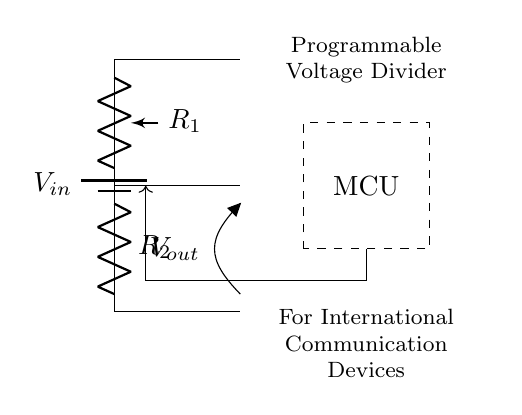What is the input voltage represented in the circuit? The input voltage is represented as "V_in" in the circuit diagram, which indicates the supply voltage for the programmable voltage divider.
Answer: V_in What type of component is R1? R1 is labeled as a "pR" in the diagram, indicating that it is a programmable resistor or potentiometer used to adjust the resistance dynamically.
Answer: Programmable resistor How is the output voltage labeled in the circuit? The output voltage is clearly labeled as "V_out" in the diagram, showing where the output can be taken from within the circuit setup.
Answer: V_out What components are in series to form the voltage divider? The two components in series are R1 and R2; they are connected in a sequential manner between the input voltage and ground, forming the voltage divider circuit.
Answer: R1 and R2 What is the role of the microcontroller (MCU) indicated in the circuit? The microcontroller (MCU) serves to control the programmable resistor based on the requirements of different communication devices, enabling adaptable power requirements during operations.
Answer: Control voltage adjustment What is the purpose of the dashed rectangle in the circuit? The dashed rectangle represents the microcontroller, indicating that it is a separate component tasked with processing control signals to adjust the voltage output, making the circuit adaptable.
Answer: Microcontroller What functionality does the programmable voltage divider provide in joint operations? The programmable voltage divider allows for the adaptation of voltage levels to match the varied power requirements of different countries' communication devices used in joint operations, ensuring compatibility.
Answer: Voltage adaptation 